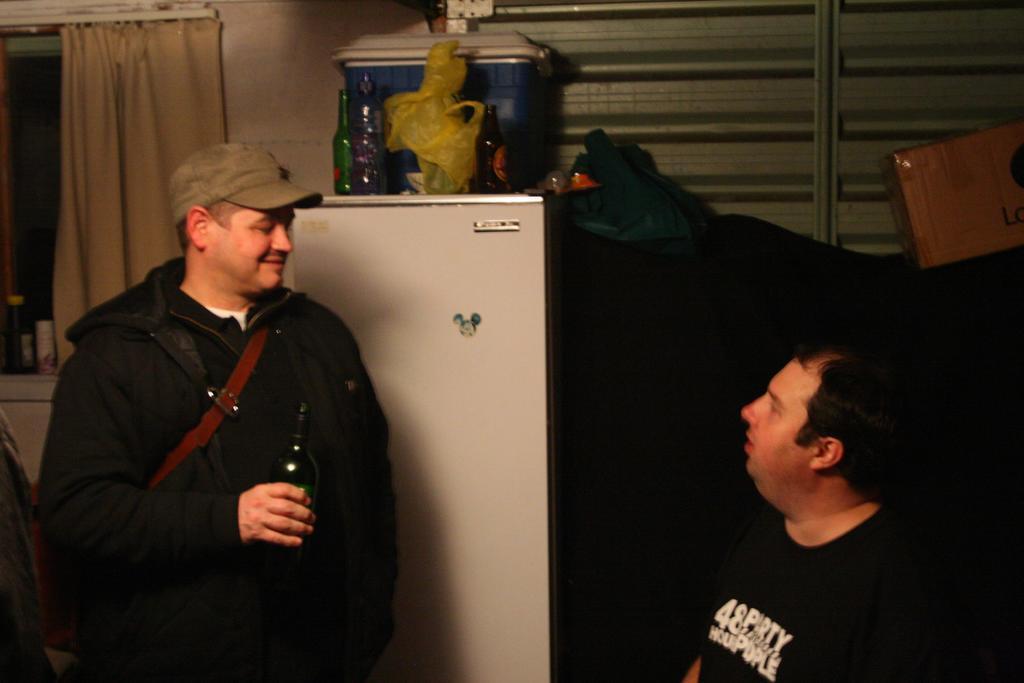Could you give a brief overview of what you see in this image? In the center of the image there is a person holding a bottle in his hand wearing a cap. To the right side of the image there is a person. In the background of the image there is a refrigerator. In the background of the image there is a window with a curtain. There is a wall. 